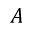<formula> <loc_0><loc_0><loc_500><loc_500>A</formula> 